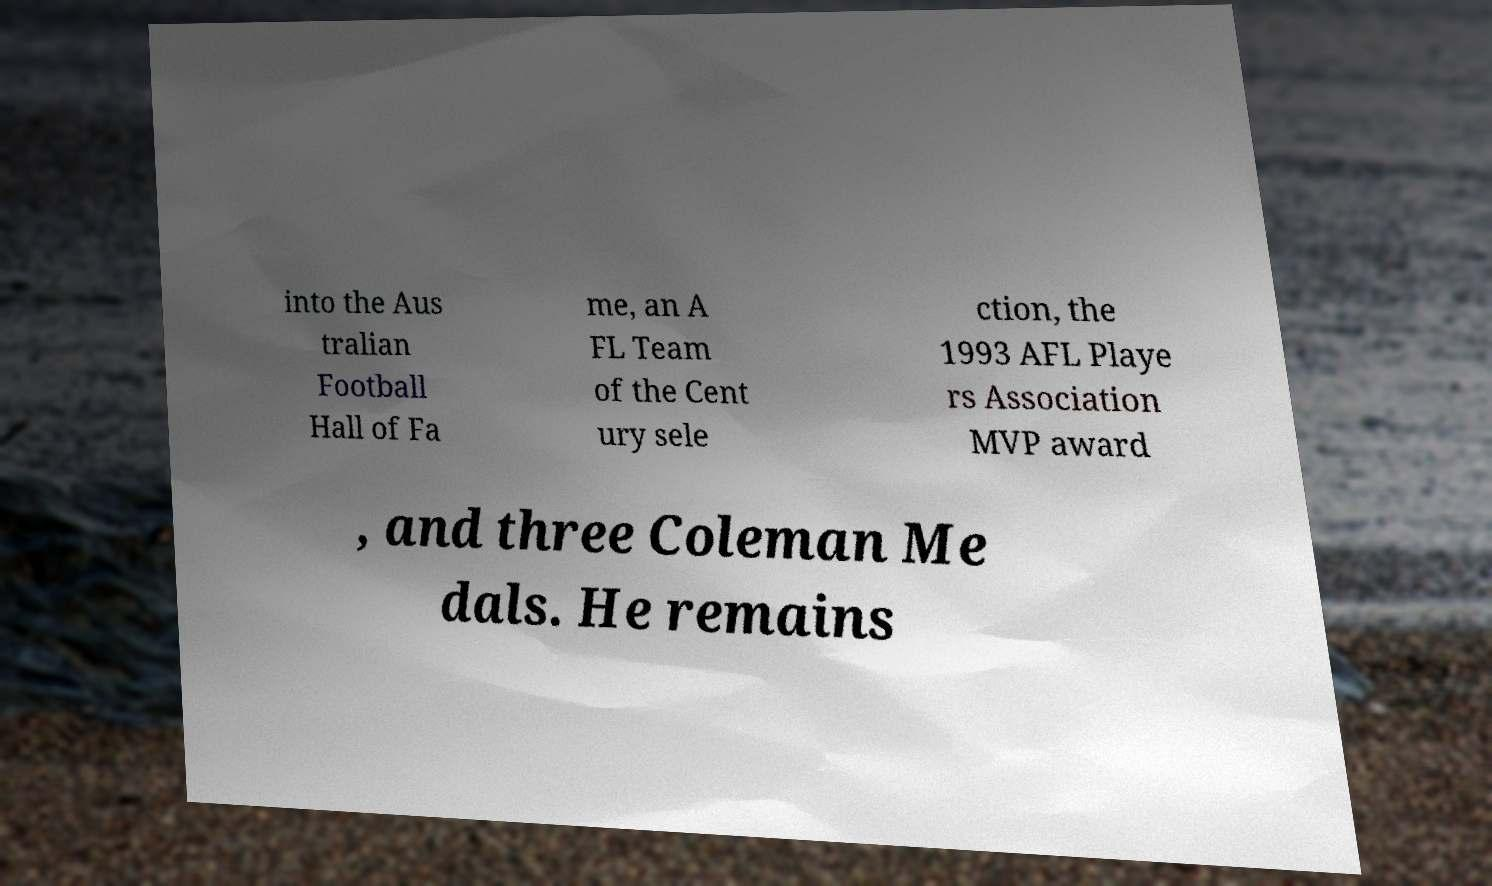Can you accurately transcribe the text from the provided image for me? into the Aus tralian Football Hall of Fa me, an A FL Team of the Cent ury sele ction, the 1993 AFL Playe rs Association MVP award , and three Coleman Me dals. He remains 